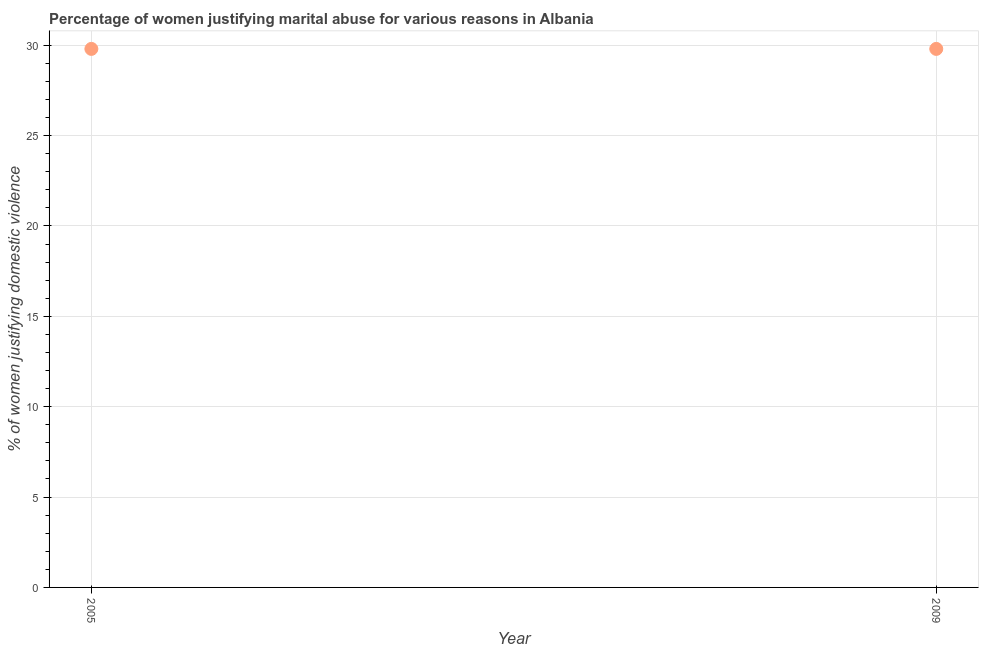What is the percentage of women justifying marital abuse in 2005?
Your answer should be compact. 29.8. Across all years, what is the maximum percentage of women justifying marital abuse?
Offer a terse response. 29.8. Across all years, what is the minimum percentage of women justifying marital abuse?
Make the answer very short. 29.8. What is the sum of the percentage of women justifying marital abuse?
Keep it short and to the point. 59.6. What is the difference between the percentage of women justifying marital abuse in 2005 and 2009?
Provide a succinct answer. 0. What is the average percentage of women justifying marital abuse per year?
Ensure brevity in your answer.  29.8. What is the median percentage of women justifying marital abuse?
Provide a succinct answer. 29.8. In how many years, is the percentage of women justifying marital abuse greater than 4 %?
Your answer should be very brief. 2. Do a majority of the years between 2009 and 2005 (inclusive) have percentage of women justifying marital abuse greater than 9 %?
Offer a very short reply. No. What is the ratio of the percentage of women justifying marital abuse in 2005 to that in 2009?
Offer a very short reply. 1. In how many years, is the percentage of women justifying marital abuse greater than the average percentage of women justifying marital abuse taken over all years?
Provide a short and direct response. 0. Does the percentage of women justifying marital abuse monotonically increase over the years?
Your answer should be very brief. No. How many dotlines are there?
Make the answer very short. 1. How many years are there in the graph?
Your answer should be very brief. 2. What is the difference between two consecutive major ticks on the Y-axis?
Your answer should be very brief. 5. Does the graph contain any zero values?
Provide a succinct answer. No. What is the title of the graph?
Keep it short and to the point. Percentage of women justifying marital abuse for various reasons in Albania. What is the label or title of the X-axis?
Provide a short and direct response. Year. What is the label or title of the Y-axis?
Give a very brief answer. % of women justifying domestic violence. What is the % of women justifying domestic violence in 2005?
Your answer should be very brief. 29.8. What is the % of women justifying domestic violence in 2009?
Offer a very short reply. 29.8. What is the ratio of the % of women justifying domestic violence in 2005 to that in 2009?
Provide a succinct answer. 1. 